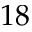<formula> <loc_0><loc_0><loc_500><loc_500>1 8</formula> 